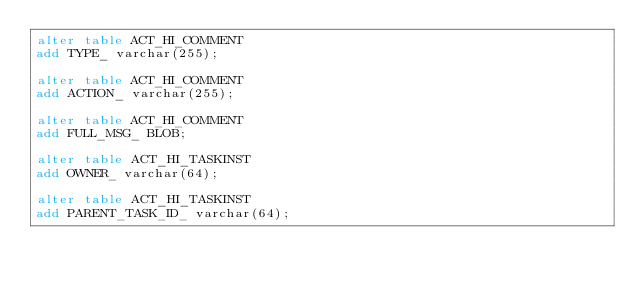<code> <loc_0><loc_0><loc_500><loc_500><_SQL_>alter table ACT_HI_COMMENT 
add TYPE_ varchar(255);

alter table ACT_HI_COMMENT 
add ACTION_ varchar(255);

alter table ACT_HI_COMMENT 
add FULL_MSG_ BLOB;

alter table ACT_HI_TASKINST 
add OWNER_ varchar(64);

alter table ACT_HI_TASKINST 
add PARENT_TASK_ID_ varchar(64);
</code> 